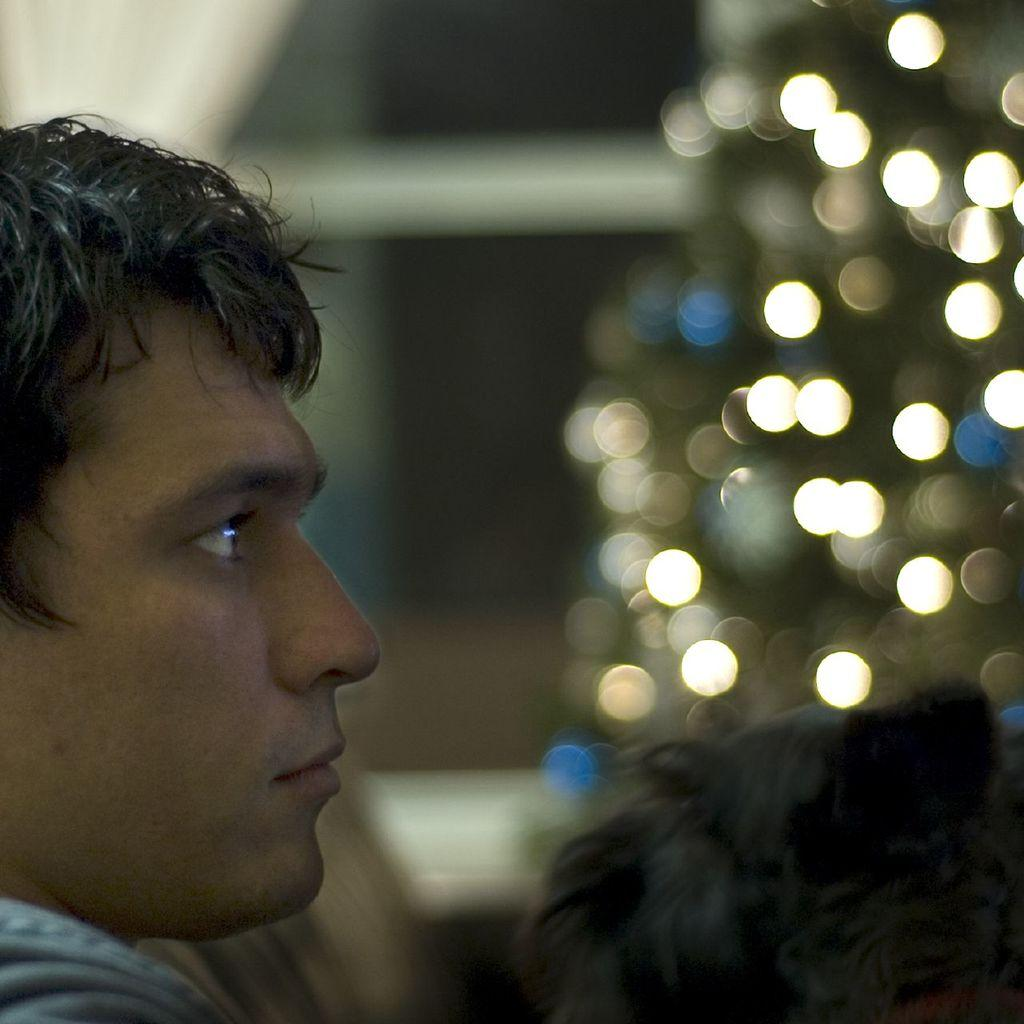How many people are present in the image? The number of people in the image cannot be determined from the provided facts. What can be seen in the background of the image? There are lights visible in the background of the image. What type of cable is being used by the hen in the image? There is no hen or cable present in the image. How does the mother interact with the people in the image? There is no mention of a mother in the image, so it is not possible to answer this question. 